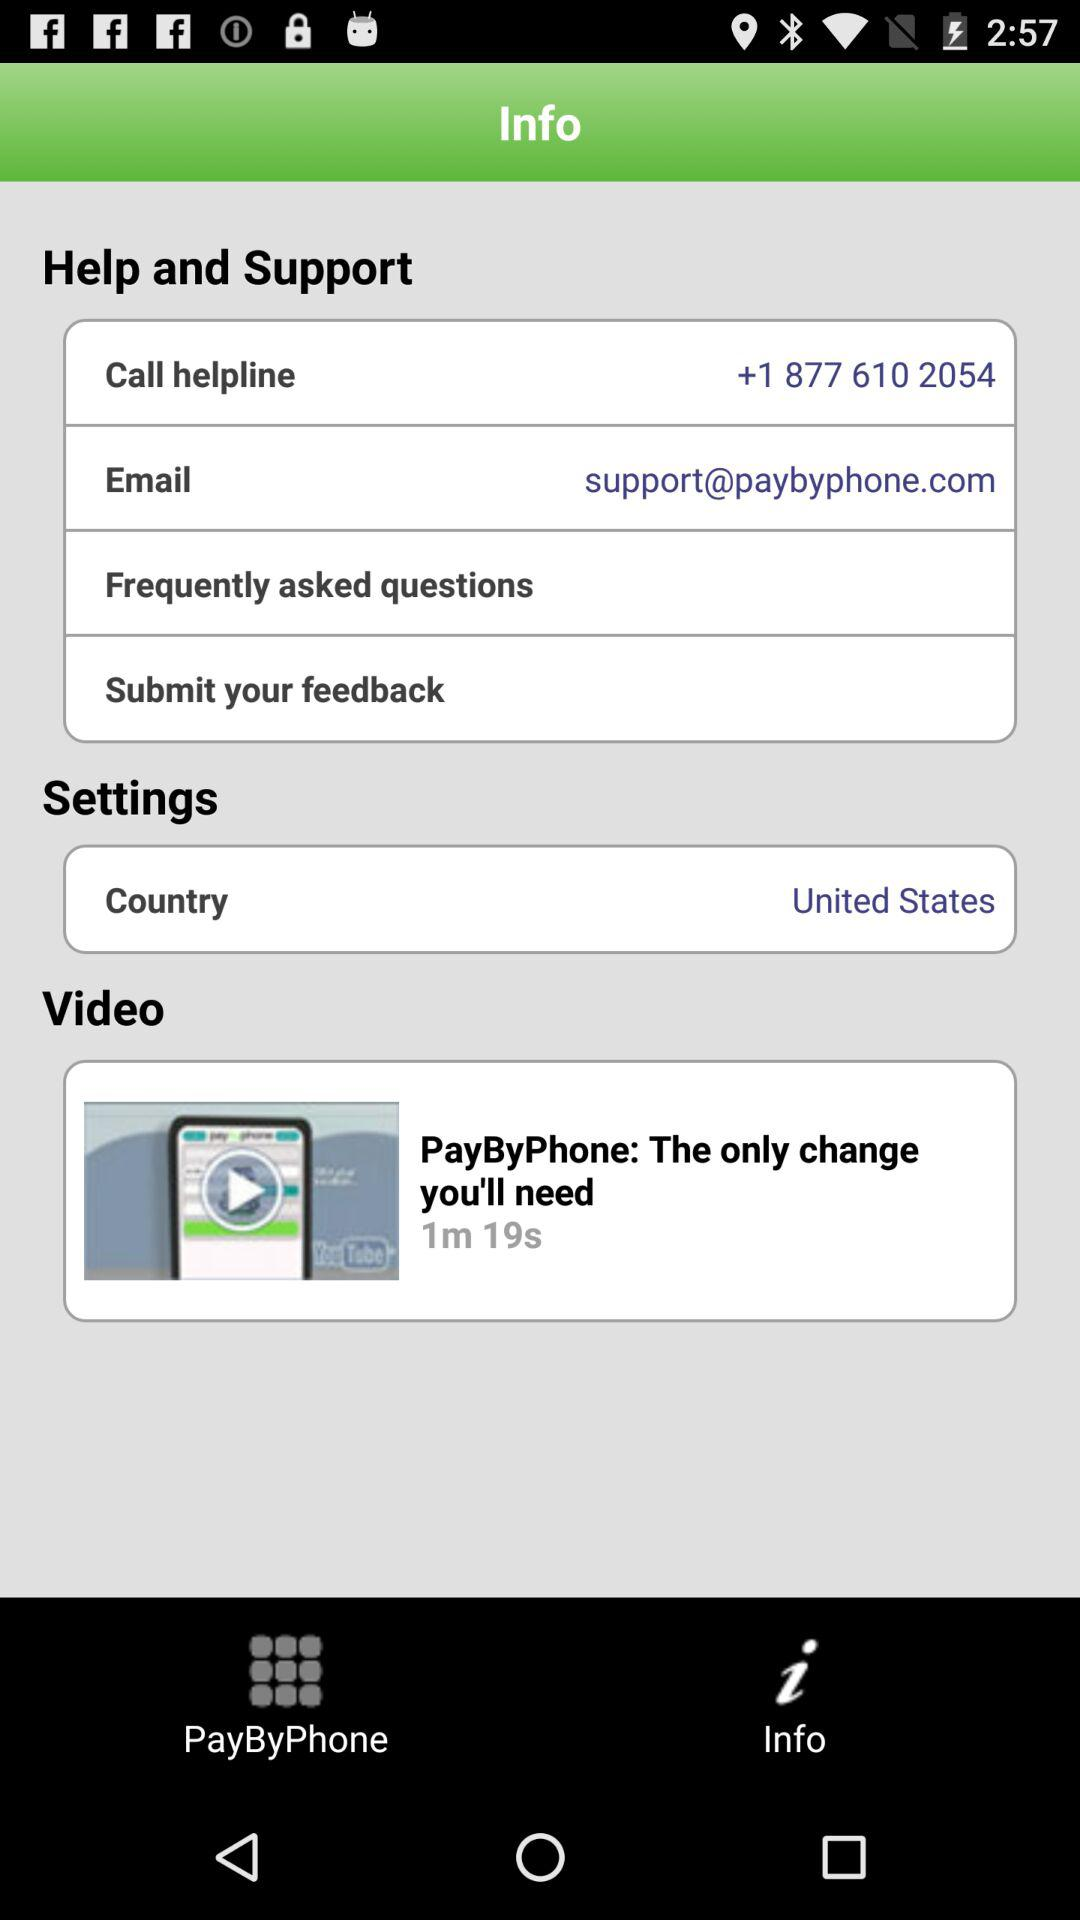Which tab is selected on the page? The selected tab is "Info". 